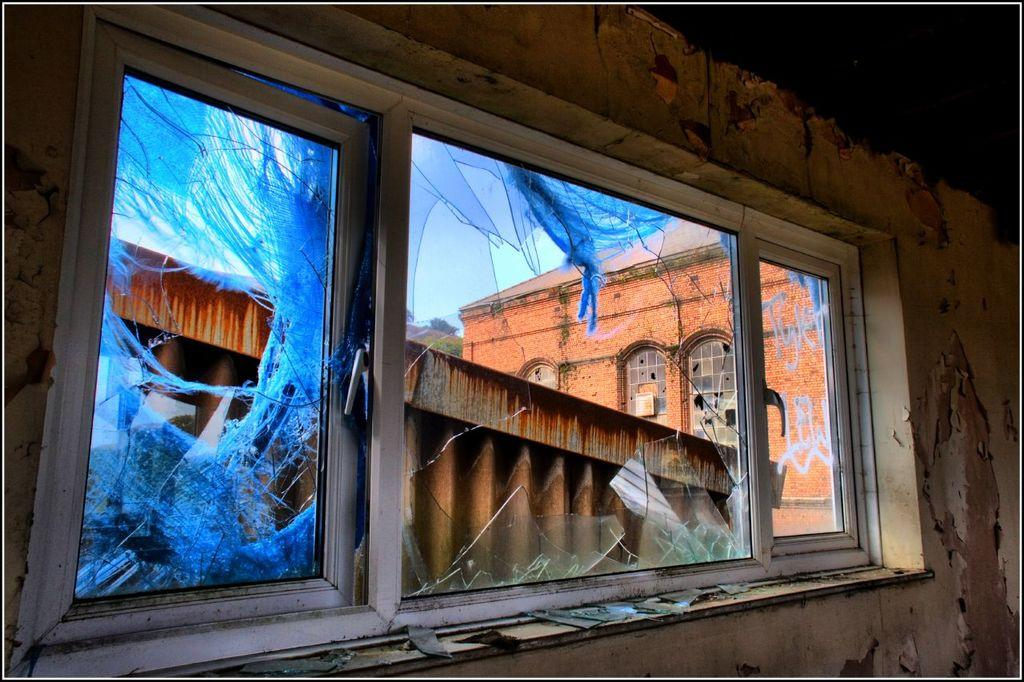What is the condition of the glass window in the image? The glass window in the image is broken. What type of building is visible behind the window? There is a red color brick building behind the window. What caption is written on the broken glass window in the image? There is no caption written on the broken glass window in the image. Can you see any friends playing near the building in the image? There is no mention of friends or any play activity in the image. 